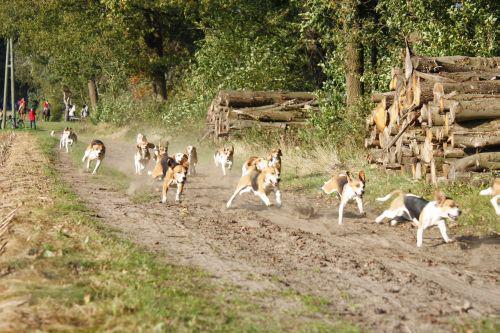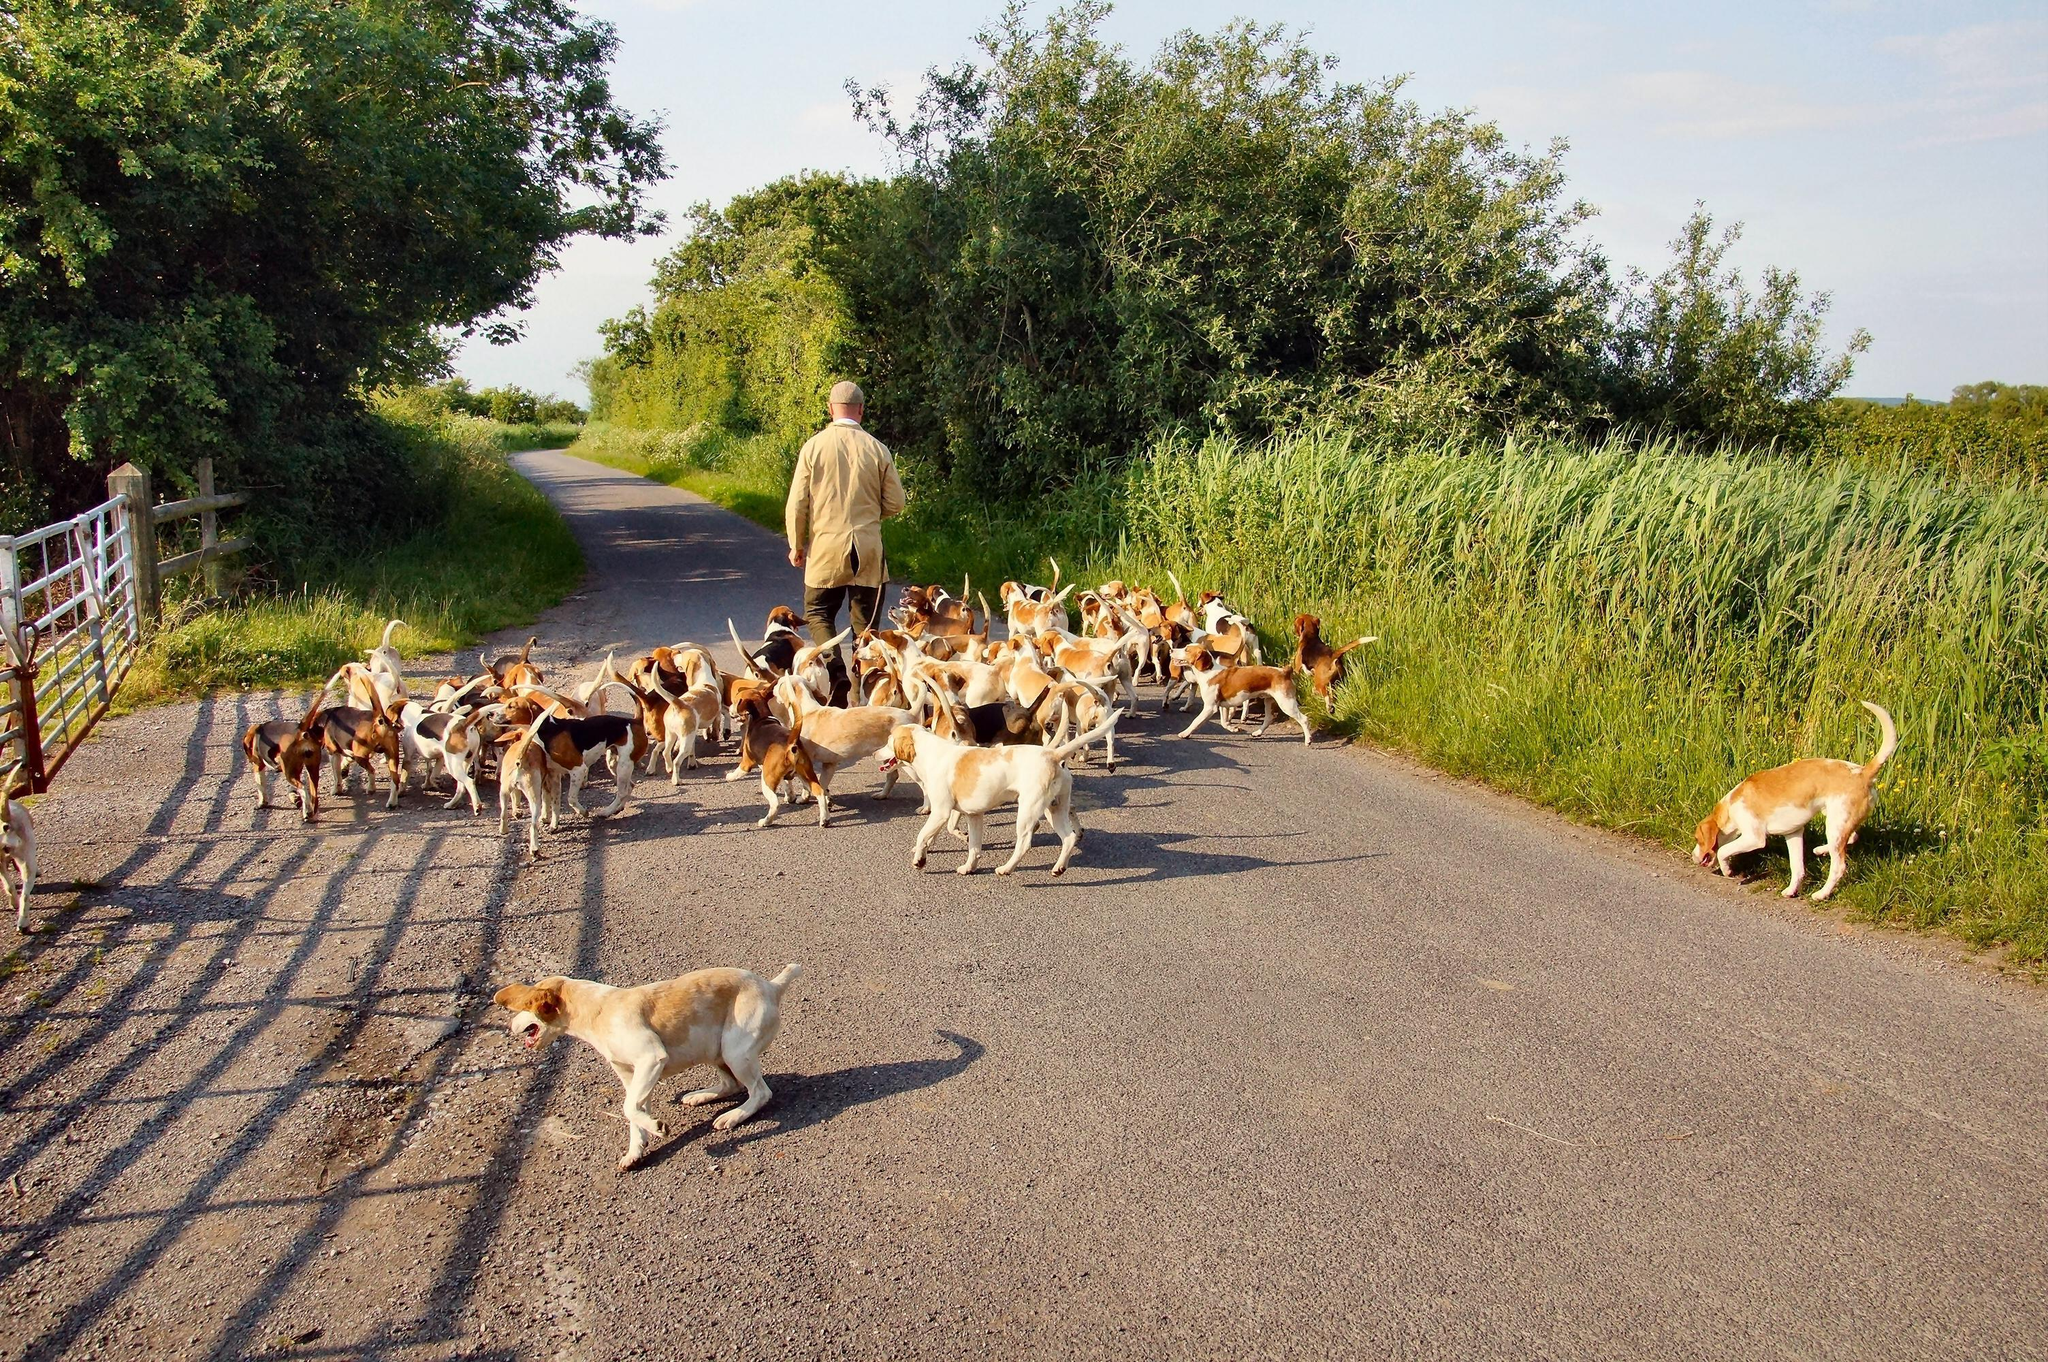The first image is the image on the left, the second image is the image on the right. Assess this claim about the two images: "An image contains a large herd of dogs following a man on a horse that is wearing a red jacket.". Correct or not? Answer yes or no. No. The first image is the image on the left, the second image is the image on the right. Given the left and right images, does the statement "There are dogs and horses." hold true? Answer yes or no. No. 